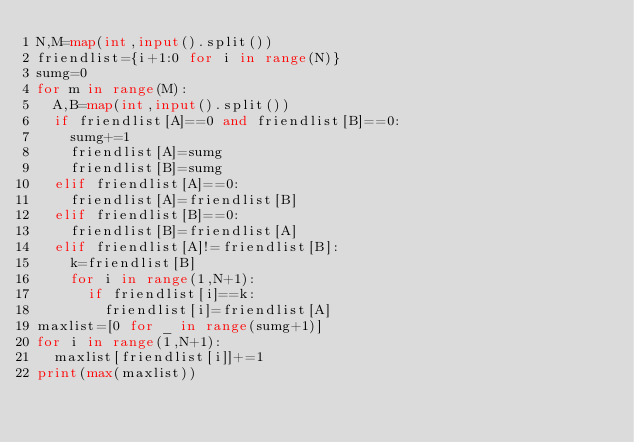<code> <loc_0><loc_0><loc_500><loc_500><_Python_>N,M=map(int,input().split())
friendlist={i+1:0 for i in range(N)}
sumg=0
for m in range(M):
  A,B=map(int,input().split())
  if friendlist[A]==0 and friendlist[B]==0:
    sumg+=1
    friendlist[A]=sumg
    friendlist[B]=sumg
  elif friendlist[A]==0:
    friendlist[A]=friendlist[B]
  elif friendlist[B]==0:
    friendlist[B]=friendlist[A]
  elif friendlist[A]!=friendlist[B]:
    k=friendlist[B]
    for i in range(1,N+1):
      if friendlist[i]==k:
        friendlist[i]=friendlist[A]
maxlist=[0 for _ in range(sumg+1)]
for i in range(1,N+1):
  maxlist[friendlist[i]]+=1
print(max(maxlist))</code> 